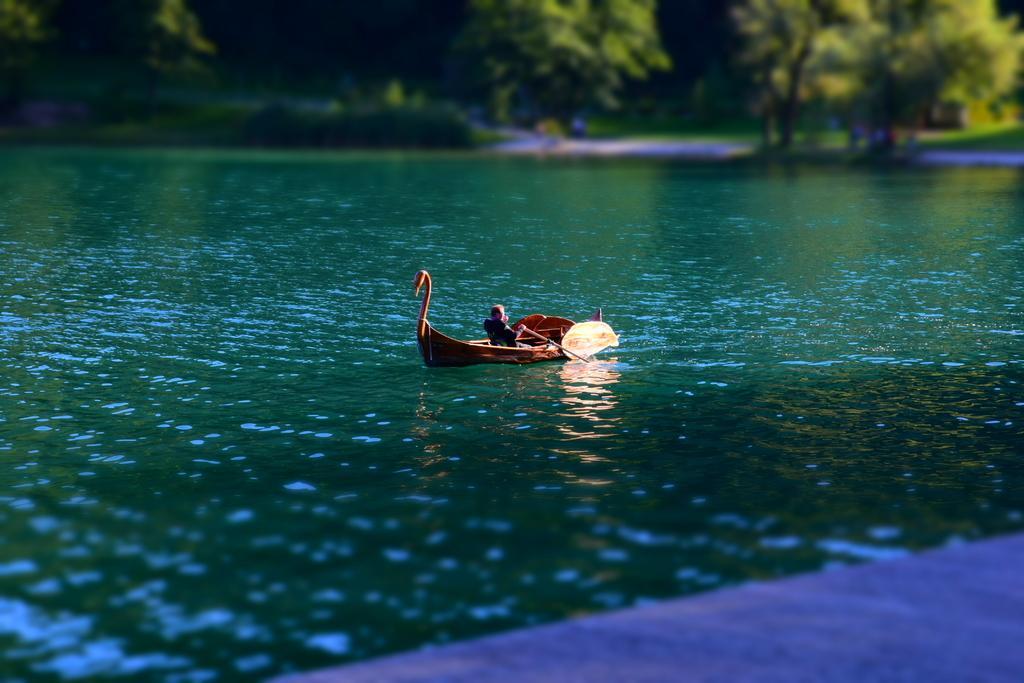In one or two sentences, can you explain what this image depicts? In the picture we can see the water surface in it we can see a boat with a person sitting and riding it and far away from it we can see some trees. 